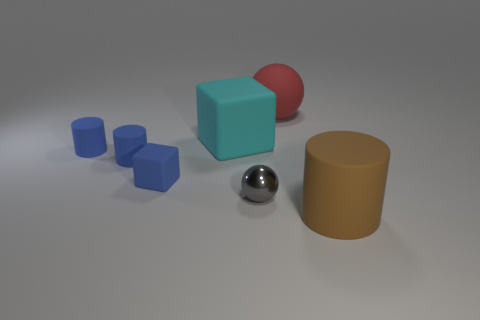Does the large red thing have the same material as the small sphere?
Provide a short and direct response. No. How many blue cylinders are behind the sphere on the right side of the small metal object?
Provide a succinct answer. 0. Are there any other objects of the same shape as the gray shiny object?
Make the answer very short. Yes. Do the big thing on the left side of the big red object and the object that is to the right of the red sphere have the same shape?
Your answer should be very brief. No. The object that is behind the small blue matte cube and on the right side of the cyan matte cube has what shape?
Provide a succinct answer. Sphere. Are there any blue objects of the same size as the red sphere?
Your response must be concise. No. Is the color of the large cylinder the same as the sphere on the right side of the gray shiny thing?
Make the answer very short. No. What is the material of the cyan object?
Your answer should be very brief. Rubber. The rubber thing behind the big cyan cube is what color?
Your answer should be compact. Red. How many large rubber blocks are the same color as the large matte cylinder?
Ensure brevity in your answer.  0. 